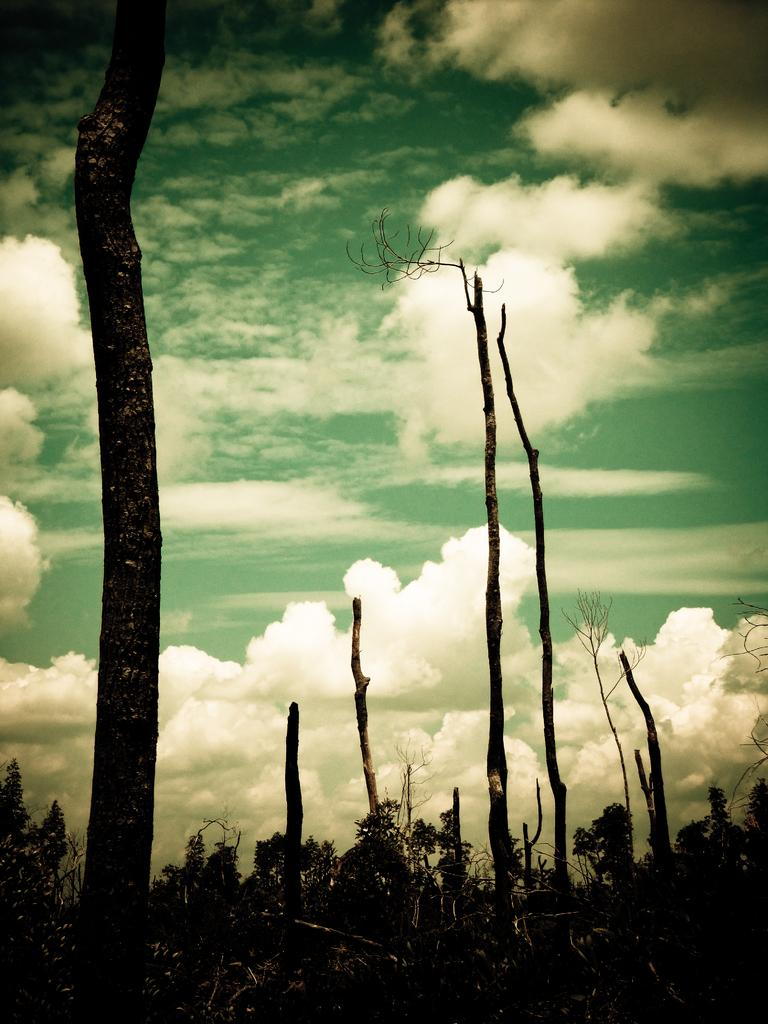What type of vegetation is present at the bottom of the image? There are trees at the bottom of the image. What part of the natural environment is visible in the background of the image? The sky is visible in the background of the image. Can you describe the sky in the image? The sky appears to be cloudy in the image. What type of sock is hanging on the tree in the image? There is no sock present in the image; it features trees and a cloudy sky. What type of coil is visible in the image? There is no coil present in the image. 